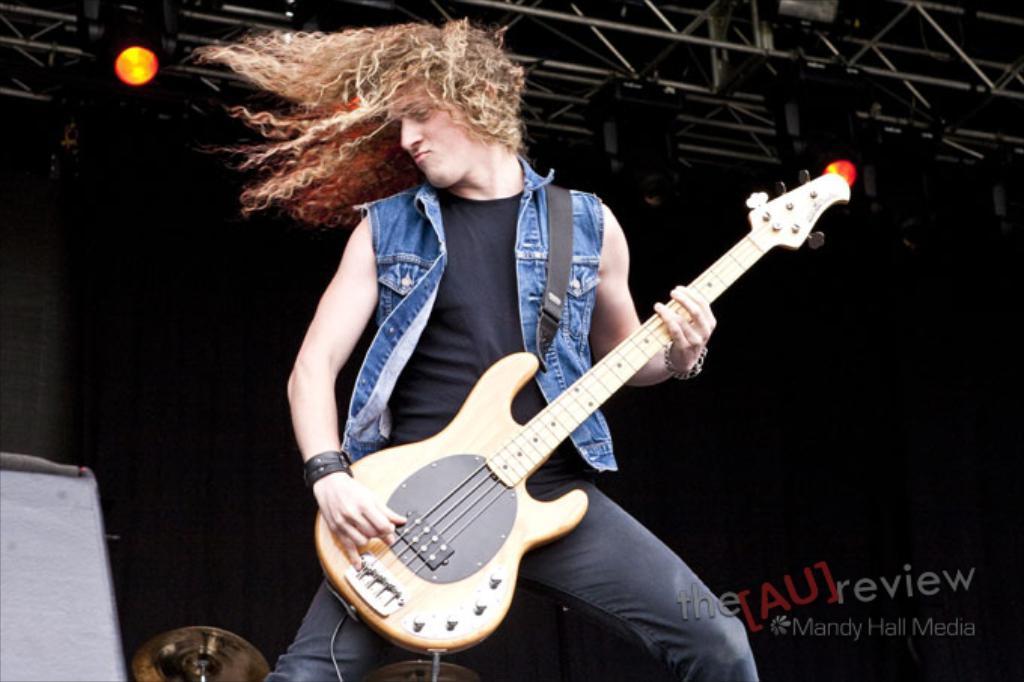Could you give a brief overview of what you see in this image? Background of the picture is very dark. This is a light. Here we can see one person standing and playing a guitar. His hair is very long and curly. This is a cymbal. 